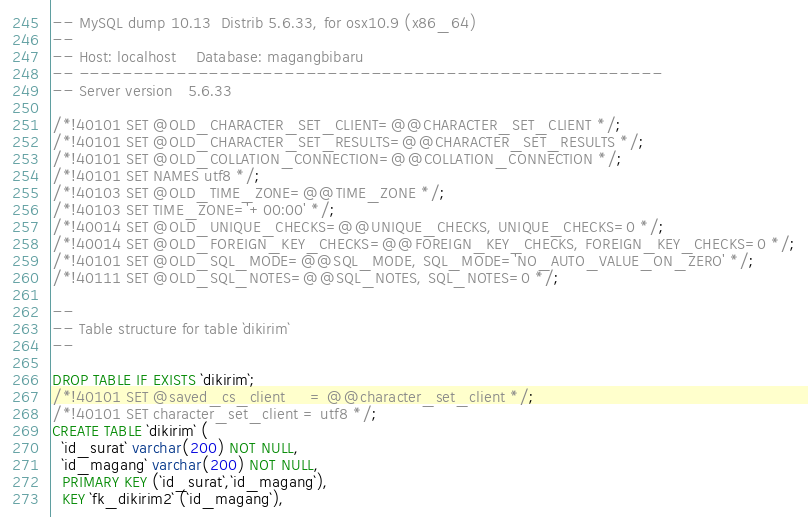Convert code to text. <code><loc_0><loc_0><loc_500><loc_500><_SQL_>-- MySQL dump 10.13  Distrib 5.6.33, for osx10.9 (x86_64)
--
-- Host: localhost    Database: magangbibaru
-- ------------------------------------------------------
-- Server version	5.6.33

/*!40101 SET @OLD_CHARACTER_SET_CLIENT=@@CHARACTER_SET_CLIENT */;
/*!40101 SET @OLD_CHARACTER_SET_RESULTS=@@CHARACTER_SET_RESULTS */;
/*!40101 SET @OLD_COLLATION_CONNECTION=@@COLLATION_CONNECTION */;
/*!40101 SET NAMES utf8 */;
/*!40103 SET @OLD_TIME_ZONE=@@TIME_ZONE */;
/*!40103 SET TIME_ZONE='+00:00' */;
/*!40014 SET @OLD_UNIQUE_CHECKS=@@UNIQUE_CHECKS, UNIQUE_CHECKS=0 */;
/*!40014 SET @OLD_FOREIGN_KEY_CHECKS=@@FOREIGN_KEY_CHECKS, FOREIGN_KEY_CHECKS=0 */;
/*!40101 SET @OLD_SQL_MODE=@@SQL_MODE, SQL_MODE='NO_AUTO_VALUE_ON_ZERO' */;
/*!40111 SET @OLD_SQL_NOTES=@@SQL_NOTES, SQL_NOTES=0 */;

--
-- Table structure for table `dikirim`
--

DROP TABLE IF EXISTS `dikirim`;
/*!40101 SET @saved_cs_client     = @@character_set_client */;
/*!40101 SET character_set_client = utf8 */;
CREATE TABLE `dikirim` (
  `id_surat` varchar(200) NOT NULL,
  `id_magang` varchar(200) NOT NULL,
  PRIMARY KEY (`id_surat`,`id_magang`),
  KEY `fk_dikirim2` (`id_magang`),</code> 